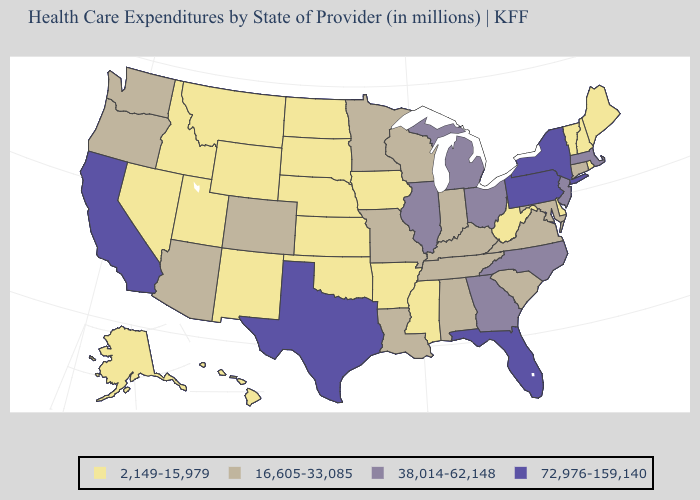Name the states that have a value in the range 2,149-15,979?
Concise answer only. Alaska, Arkansas, Delaware, Hawaii, Idaho, Iowa, Kansas, Maine, Mississippi, Montana, Nebraska, Nevada, New Hampshire, New Mexico, North Dakota, Oklahoma, Rhode Island, South Dakota, Utah, Vermont, West Virginia, Wyoming. Name the states that have a value in the range 16,605-33,085?
Be succinct. Alabama, Arizona, Colorado, Connecticut, Indiana, Kentucky, Louisiana, Maryland, Minnesota, Missouri, Oregon, South Carolina, Tennessee, Virginia, Washington, Wisconsin. What is the value of Indiana?
Give a very brief answer. 16,605-33,085. Does Ohio have a lower value than Florida?
Quick response, please. Yes. Does Arkansas have a lower value than New Jersey?
Keep it brief. Yes. Which states have the lowest value in the Northeast?
Write a very short answer. Maine, New Hampshire, Rhode Island, Vermont. What is the highest value in states that border Wyoming?
Keep it brief. 16,605-33,085. Name the states that have a value in the range 38,014-62,148?
Quick response, please. Georgia, Illinois, Massachusetts, Michigan, New Jersey, North Carolina, Ohio. Does South Dakota have the highest value in the MidWest?
Keep it brief. No. What is the value of South Carolina?
Answer briefly. 16,605-33,085. What is the value of Oregon?
Be succinct. 16,605-33,085. Among the states that border Montana , which have the lowest value?
Short answer required. Idaho, North Dakota, South Dakota, Wyoming. Which states have the highest value in the USA?
Write a very short answer. California, Florida, New York, Pennsylvania, Texas. Does Maine have the lowest value in the Northeast?
Give a very brief answer. Yes. Name the states that have a value in the range 16,605-33,085?
Quick response, please. Alabama, Arizona, Colorado, Connecticut, Indiana, Kentucky, Louisiana, Maryland, Minnesota, Missouri, Oregon, South Carolina, Tennessee, Virginia, Washington, Wisconsin. 